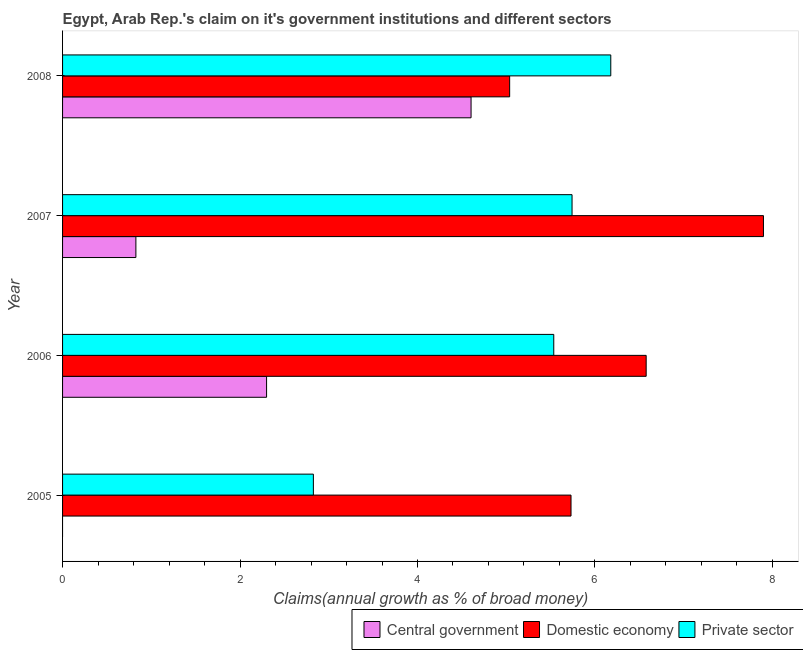How many different coloured bars are there?
Your answer should be compact. 3. How many groups of bars are there?
Offer a terse response. 4. How many bars are there on the 1st tick from the top?
Provide a short and direct response. 3. How many bars are there on the 3rd tick from the bottom?
Offer a terse response. 3. In how many cases, is the number of bars for a given year not equal to the number of legend labels?
Offer a very short reply. 1. What is the percentage of claim on the central government in 2005?
Your answer should be compact. 0. Across all years, what is the maximum percentage of claim on the domestic economy?
Provide a succinct answer. 7.9. Across all years, what is the minimum percentage of claim on the domestic economy?
Ensure brevity in your answer.  5.04. What is the total percentage of claim on the domestic economy in the graph?
Provide a short and direct response. 25.25. What is the difference between the percentage of claim on the domestic economy in 2005 and that in 2008?
Provide a short and direct response. 0.69. What is the difference between the percentage of claim on the private sector in 2006 and the percentage of claim on the central government in 2008?
Provide a short and direct response. 0.93. What is the average percentage of claim on the central government per year?
Your response must be concise. 1.93. In the year 2008, what is the difference between the percentage of claim on the private sector and percentage of claim on the central government?
Your answer should be compact. 1.57. What is the ratio of the percentage of claim on the private sector in 2006 to that in 2007?
Your response must be concise. 0.96. Is the percentage of claim on the private sector in 2007 less than that in 2008?
Your response must be concise. Yes. Is the difference between the percentage of claim on the private sector in 2005 and 2007 greater than the difference between the percentage of claim on the domestic economy in 2005 and 2007?
Provide a short and direct response. No. What is the difference between the highest and the second highest percentage of claim on the private sector?
Your answer should be very brief. 0.44. What is the difference between the highest and the lowest percentage of claim on the domestic economy?
Keep it short and to the point. 2.86. Are all the bars in the graph horizontal?
Your answer should be compact. Yes. Are the values on the major ticks of X-axis written in scientific E-notation?
Give a very brief answer. No. Where does the legend appear in the graph?
Make the answer very short. Bottom right. What is the title of the graph?
Give a very brief answer. Egypt, Arab Rep.'s claim on it's government institutions and different sectors. What is the label or title of the X-axis?
Offer a very short reply. Claims(annual growth as % of broad money). What is the label or title of the Y-axis?
Give a very brief answer. Year. What is the Claims(annual growth as % of broad money) of Central government in 2005?
Provide a short and direct response. 0. What is the Claims(annual growth as % of broad money) of Domestic economy in 2005?
Keep it short and to the point. 5.73. What is the Claims(annual growth as % of broad money) in Private sector in 2005?
Offer a very short reply. 2.83. What is the Claims(annual growth as % of broad money) of Central government in 2006?
Offer a very short reply. 2.3. What is the Claims(annual growth as % of broad money) of Domestic economy in 2006?
Ensure brevity in your answer.  6.58. What is the Claims(annual growth as % of broad money) of Private sector in 2006?
Offer a very short reply. 5.54. What is the Claims(annual growth as % of broad money) in Central government in 2007?
Provide a short and direct response. 0.83. What is the Claims(annual growth as % of broad money) of Domestic economy in 2007?
Ensure brevity in your answer.  7.9. What is the Claims(annual growth as % of broad money) of Private sector in 2007?
Ensure brevity in your answer.  5.74. What is the Claims(annual growth as % of broad money) in Central government in 2008?
Give a very brief answer. 4.6. What is the Claims(annual growth as % of broad money) of Domestic economy in 2008?
Provide a short and direct response. 5.04. What is the Claims(annual growth as % of broad money) of Private sector in 2008?
Ensure brevity in your answer.  6.18. Across all years, what is the maximum Claims(annual growth as % of broad money) of Central government?
Your response must be concise. 4.6. Across all years, what is the maximum Claims(annual growth as % of broad money) of Domestic economy?
Your response must be concise. 7.9. Across all years, what is the maximum Claims(annual growth as % of broad money) in Private sector?
Offer a very short reply. 6.18. Across all years, what is the minimum Claims(annual growth as % of broad money) of Central government?
Offer a very short reply. 0. Across all years, what is the minimum Claims(annual growth as % of broad money) of Domestic economy?
Ensure brevity in your answer.  5.04. Across all years, what is the minimum Claims(annual growth as % of broad money) of Private sector?
Offer a very short reply. 2.83. What is the total Claims(annual growth as % of broad money) in Central government in the graph?
Provide a succinct answer. 7.73. What is the total Claims(annual growth as % of broad money) in Domestic economy in the graph?
Offer a terse response. 25.25. What is the total Claims(annual growth as % of broad money) of Private sector in the graph?
Give a very brief answer. 20.28. What is the difference between the Claims(annual growth as % of broad money) in Domestic economy in 2005 and that in 2006?
Give a very brief answer. -0.85. What is the difference between the Claims(annual growth as % of broad money) in Private sector in 2005 and that in 2006?
Your answer should be compact. -2.71. What is the difference between the Claims(annual growth as % of broad money) of Domestic economy in 2005 and that in 2007?
Make the answer very short. -2.17. What is the difference between the Claims(annual growth as % of broad money) in Private sector in 2005 and that in 2007?
Provide a succinct answer. -2.92. What is the difference between the Claims(annual growth as % of broad money) of Domestic economy in 2005 and that in 2008?
Your answer should be compact. 0.69. What is the difference between the Claims(annual growth as % of broad money) of Private sector in 2005 and that in 2008?
Provide a short and direct response. -3.35. What is the difference between the Claims(annual growth as % of broad money) in Central government in 2006 and that in 2007?
Your answer should be very brief. 1.47. What is the difference between the Claims(annual growth as % of broad money) in Domestic economy in 2006 and that in 2007?
Make the answer very short. -1.32. What is the difference between the Claims(annual growth as % of broad money) of Private sector in 2006 and that in 2007?
Keep it short and to the point. -0.21. What is the difference between the Claims(annual growth as % of broad money) in Central government in 2006 and that in 2008?
Ensure brevity in your answer.  -2.3. What is the difference between the Claims(annual growth as % of broad money) in Domestic economy in 2006 and that in 2008?
Your answer should be very brief. 1.54. What is the difference between the Claims(annual growth as % of broad money) of Private sector in 2006 and that in 2008?
Give a very brief answer. -0.64. What is the difference between the Claims(annual growth as % of broad money) in Central government in 2007 and that in 2008?
Provide a succinct answer. -3.78. What is the difference between the Claims(annual growth as % of broad money) in Domestic economy in 2007 and that in 2008?
Your response must be concise. 2.86. What is the difference between the Claims(annual growth as % of broad money) of Private sector in 2007 and that in 2008?
Offer a terse response. -0.44. What is the difference between the Claims(annual growth as % of broad money) of Domestic economy in 2005 and the Claims(annual growth as % of broad money) of Private sector in 2006?
Provide a succinct answer. 0.19. What is the difference between the Claims(annual growth as % of broad money) in Domestic economy in 2005 and the Claims(annual growth as % of broad money) in Private sector in 2007?
Your response must be concise. -0.01. What is the difference between the Claims(annual growth as % of broad money) in Domestic economy in 2005 and the Claims(annual growth as % of broad money) in Private sector in 2008?
Your answer should be compact. -0.45. What is the difference between the Claims(annual growth as % of broad money) of Central government in 2006 and the Claims(annual growth as % of broad money) of Domestic economy in 2007?
Provide a short and direct response. -5.6. What is the difference between the Claims(annual growth as % of broad money) of Central government in 2006 and the Claims(annual growth as % of broad money) of Private sector in 2007?
Provide a short and direct response. -3.44. What is the difference between the Claims(annual growth as % of broad money) in Domestic economy in 2006 and the Claims(annual growth as % of broad money) in Private sector in 2007?
Offer a terse response. 0.84. What is the difference between the Claims(annual growth as % of broad money) in Central government in 2006 and the Claims(annual growth as % of broad money) in Domestic economy in 2008?
Provide a short and direct response. -2.74. What is the difference between the Claims(annual growth as % of broad money) in Central government in 2006 and the Claims(annual growth as % of broad money) in Private sector in 2008?
Ensure brevity in your answer.  -3.88. What is the difference between the Claims(annual growth as % of broad money) in Domestic economy in 2006 and the Claims(annual growth as % of broad money) in Private sector in 2008?
Offer a very short reply. 0.4. What is the difference between the Claims(annual growth as % of broad money) of Central government in 2007 and the Claims(annual growth as % of broad money) of Domestic economy in 2008?
Offer a very short reply. -4.21. What is the difference between the Claims(annual growth as % of broad money) in Central government in 2007 and the Claims(annual growth as % of broad money) in Private sector in 2008?
Ensure brevity in your answer.  -5.35. What is the difference between the Claims(annual growth as % of broad money) in Domestic economy in 2007 and the Claims(annual growth as % of broad money) in Private sector in 2008?
Provide a short and direct response. 1.72. What is the average Claims(annual growth as % of broad money) of Central government per year?
Your response must be concise. 1.93. What is the average Claims(annual growth as % of broad money) in Domestic economy per year?
Your response must be concise. 6.31. What is the average Claims(annual growth as % of broad money) in Private sector per year?
Ensure brevity in your answer.  5.07. In the year 2005, what is the difference between the Claims(annual growth as % of broad money) in Domestic economy and Claims(annual growth as % of broad money) in Private sector?
Your answer should be compact. 2.9. In the year 2006, what is the difference between the Claims(annual growth as % of broad money) in Central government and Claims(annual growth as % of broad money) in Domestic economy?
Keep it short and to the point. -4.28. In the year 2006, what is the difference between the Claims(annual growth as % of broad money) in Central government and Claims(annual growth as % of broad money) in Private sector?
Ensure brevity in your answer.  -3.24. In the year 2006, what is the difference between the Claims(annual growth as % of broad money) of Domestic economy and Claims(annual growth as % of broad money) of Private sector?
Your answer should be compact. 1.04. In the year 2007, what is the difference between the Claims(annual growth as % of broad money) in Central government and Claims(annual growth as % of broad money) in Domestic economy?
Provide a short and direct response. -7.07. In the year 2007, what is the difference between the Claims(annual growth as % of broad money) of Central government and Claims(annual growth as % of broad money) of Private sector?
Offer a terse response. -4.92. In the year 2007, what is the difference between the Claims(annual growth as % of broad money) of Domestic economy and Claims(annual growth as % of broad money) of Private sector?
Your answer should be compact. 2.16. In the year 2008, what is the difference between the Claims(annual growth as % of broad money) of Central government and Claims(annual growth as % of broad money) of Domestic economy?
Keep it short and to the point. -0.43. In the year 2008, what is the difference between the Claims(annual growth as % of broad money) of Central government and Claims(annual growth as % of broad money) of Private sector?
Provide a succinct answer. -1.57. In the year 2008, what is the difference between the Claims(annual growth as % of broad money) of Domestic economy and Claims(annual growth as % of broad money) of Private sector?
Ensure brevity in your answer.  -1.14. What is the ratio of the Claims(annual growth as % of broad money) of Domestic economy in 2005 to that in 2006?
Provide a succinct answer. 0.87. What is the ratio of the Claims(annual growth as % of broad money) of Private sector in 2005 to that in 2006?
Your response must be concise. 0.51. What is the ratio of the Claims(annual growth as % of broad money) in Domestic economy in 2005 to that in 2007?
Provide a succinct answer. 0.73. What is the ratio of the Claims(annual growth as % of broad money) of Private sector in 2005 to that in 2007?
Your response must be concise. 0.49. What is the ratio of the Claims(annual growth as % of broad money) in Domestic economy in 2005 to that in 2008?
Make the answer very short. 1.14. What is the ratio of the Claims(annual growth as % of broad money) of Private sector in 2005 to that in 2008?
Your answer should be very brief. 0.46. What is the ratio of the Claims(annual growth as % of broad money) of Central government in 2006 to that in 2007?
Your answer should be compact. 2.78. What is the ratio of the Claims(annual growth as % of broad money) of Domestic economy in 2006 to that in 2007?
Keep it short and to the point. 0.83. What is the ratio of the Claims(annual growth as % of broad money) of Private sector in 2006 to that in 2007?
Make the answer very short. 0.96. What is the ratio of the Claims(annual growth as % of broad money) of Central government in 2006 to that in 2008?
Provide a succinct answer. 0.5. What is the ratio of the Claims(annual growth as % of broad money) of Domestic economy in 2006 to that in 2008?
Your answer should be compact. 1.31. What is the ratio of the Claims(annual growth as % of broad money) of Private sector in 2006 to that in 2008?
Ensure brevity in your answer.  0.9. What is the ratio of the Claims(annual growth as % of broad money) of Central government in 2007 to that in 2008?
Provide a succinct answer. 0.18. What is the ratio of the Claims(annual growth as % of broad money) of Domestic economy in 2007 to that in 2008?
Provide a short and direct response. 1.57. What is the ratio of the Claims(annual growth as % of broad money) in Private sector in 2007 to that in 2008?
Your response must be concise. 0.93. What is the difference between the highest and the second highest Claims(annual growth as % of broad money) in Central government?
Keep it short and to the point. 2.3. What is the difference between the highest and the second highest Claims(annual growth as % of broad money) in Domestic economy?
Give a very brief answer. 1.32. What is the difference between the highest and the second highest Claims(annual growth as % of broad money) in Private sector?
Make the answer very short. 0.44. What is the difference between the highest and the lowest Claims(annual growth as % of broad money) of Central government?
Keep it short and to the point. 4.6. What is the difference between the highest and the lowest Claims(annual growth as % of broad money) of Domestic economy?
Your answer should be compact. 2.86. What is the difference between the highest and the lowest Claims(annual growth as % of broad money) in Private sector?
Keep it short and to the point. 3.35. 